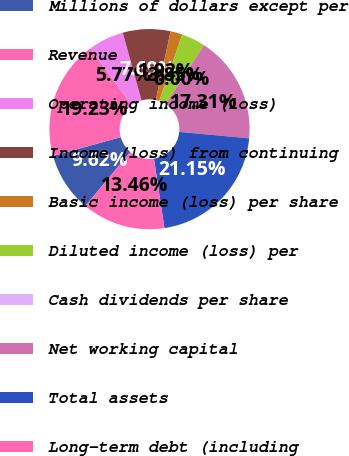Convert chart to OTSL. <chart><loc_0><loc_0><loc_500><loc_500><pie_chart><fcel>Millions of dollars except per<fcel>Revenue<fcel>Operating income (loss)<fcel>Income (loss) from continuing<fcel>Basic income (loss) per share<fcel>Diluted income (loss) per<fcel>Cash dividends per share<fcel>Net working capital<fcel>Total assets<fcel>Long-term debt (including<nl><fcel>9.62%<fcel>19.23%<fcel>5.77%<fcel>7.69%<fcel>1.92%<fcel>3.85%<fcel>0.0%<fcel>17.31%<fcel>21.15%<fcel>13.46%<nl></chart> 